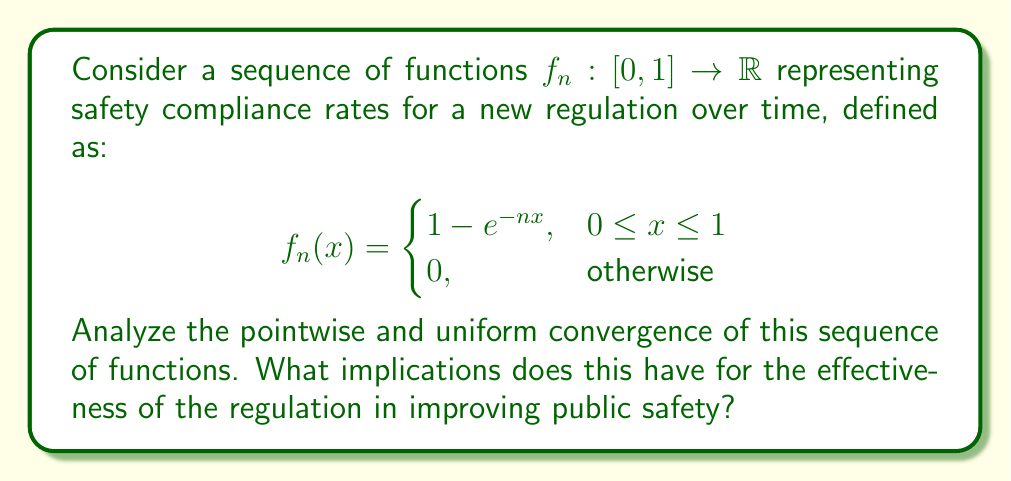Give your solution to this math problem. To analyze the convergence of this sequence of functions, we'll examine both pointwise and uniform convergence:

1. Pointwise convergence:
For any fixed $x \in [0,1]$, we need to find $\lim_{n\to\infty} f_n(x)$.

$$\lim_{n\to\infty} f_n(x) = \lim_{n\to\infty} (1 - e^{-nx})$$

Using the limit $\lim_{n\to\infty} e^{-nx} = 0$ for $x > 0$, we get:

$$f(x) = \lim_{n\to\infty} f_n(x) = \begin{cases}
1, & 0 < x \leq 1 \\
0, & x = 0
\end{cases}$$

This shows that $f_n$ converges pointwise to the function $f$ on $[0,1]$.

2. Uniform convergence:
To check for uniform convergence, we need to examine:

$$\sup_{x\in[0,1]} |f_n(x) - f(x)| = \sup_{x\in[0,1]} |e^{-nx}|$$

The supremum occurs at $x=0$, giving:

$$\sup_{x\in[0,1]} |f_n(x) - f(x)| = 1$$

Since this doesn't approach 0 as $n\to\infty$, the sequence does not converge uniformly on $[0,1]$.

However, for any closed interval $[a,1]$ with $a>0$, we have:

$$\sup_{x\in[a,1]} |f_n(x) - f(x)| = e^{-na} \to 0 \text{ as } n\to\infty$$

This shows uniform convergence on any closed subinterval of $(0,1]$.

Implications for public safety:
1. The pointwise convergence to 1 for all $x>0$ suggests that over time, the compliance rate approaches 100% for any non-zero level of enforcement.
2. The lack of uniform convergence on $[0,1]$ indicates that achieving near-perfect compliance across all levels of enforcement simultaneously may be challenging.
3. Uniform convergence on $[a,1]$ for $a>0$ implies that with a minimum threshold of enforcement, consistent high compliance can be achieved across the board.

These mathematical properties support the argument that the regulation, given sufficient enforcement, can effectively improve public safety over time.
Answer: The sequence of functions $f_n(x)$ converges pointwise to $f(x)$ on $[0,1]$, where $f(x)=1$ for $0<x\leq1$ and $f(0)=0$. It does not converge uniformly on $[0,1]$, but does converge uniformly on any closed subinterval $[a,1]$ where $a>0$. 